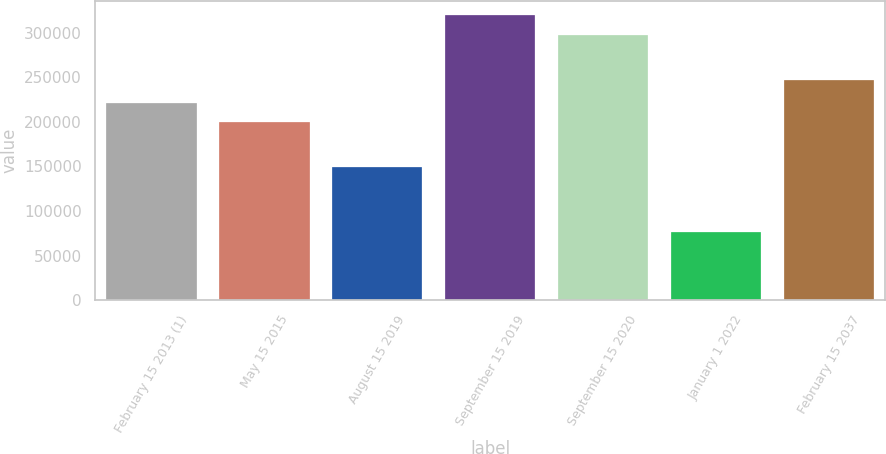<chart> <loc_0><loc_0><loc_500><loc_500><bar_chart><fcel>February 15 2013 (1)<fcel>May 15 2015<fcel>August 15 2019<fcel>September 15 2019<fcel>September 15 2020<fcel>January 1 2022<fcel>February 15 2037<nl><fcel>221584<fcel>199373<fcel>148914<fcel>319276<fcel>297065<fcel>75924<fcel>247236<nl></chart> 